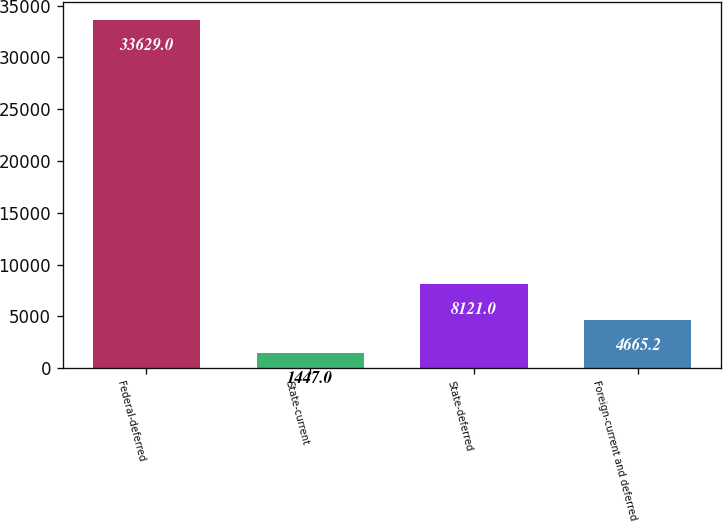<chart> <loc_0><loc_0><loc_500><loc_500><bar_chart><fcel>Federal-deferred<fcel>State-current<fcel>State-deferred<fcel>Foreign-current and deferred<nl><fcel>33629<fcel>1447<fcel>8121<fcel>4665.2<nl></chart> 